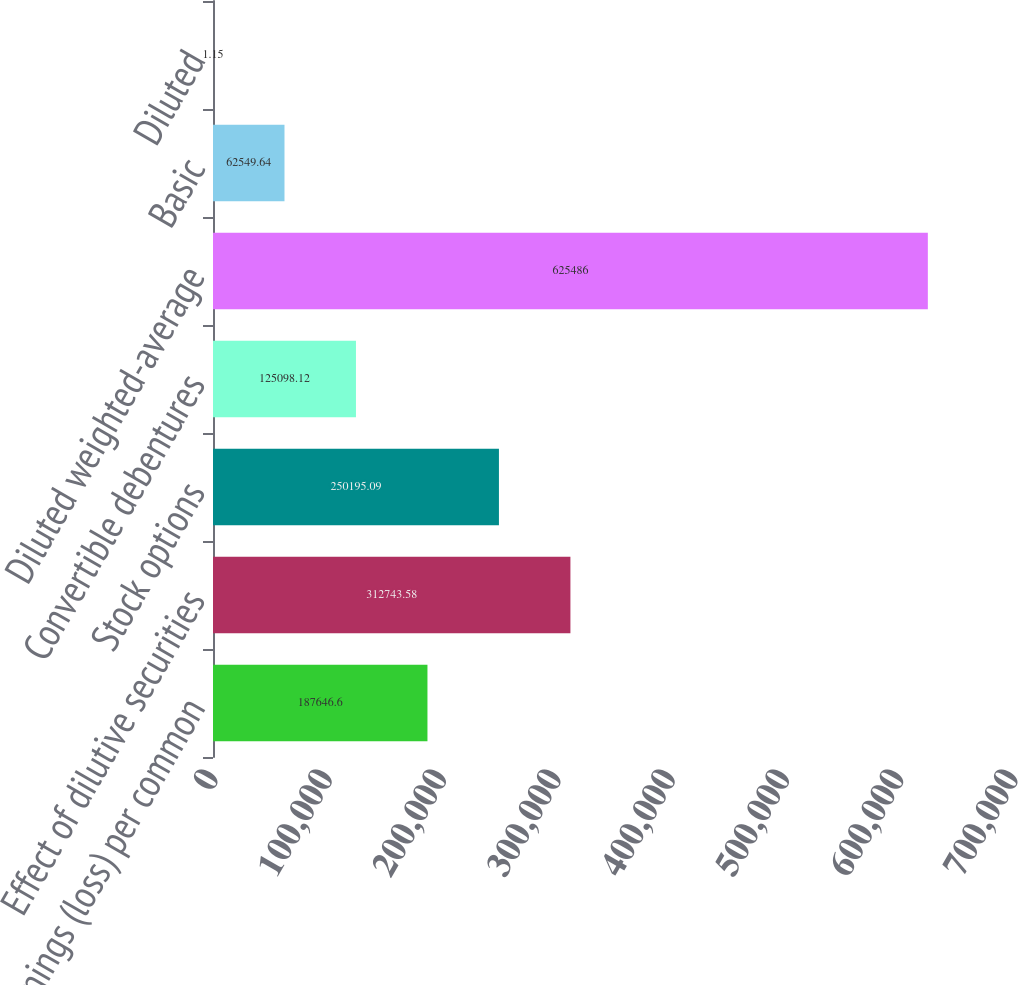Convert chart. <chart><loc_0><loc_0><loc_500><loc_500><bar_chart><fcel>earnings (loss) per common<fcel>Effect of dilutive securities<fcel>Stock options<fcel>Convertible debentures<fcel>Diluted weighted-average<fcel>Basic<fcel>Diluted<nl><fcel>187647<fcel>312744<fcel>250195<fcel>125098<fcel>625486<fcel>62549.6<fcel>1.15<nl></chart> 